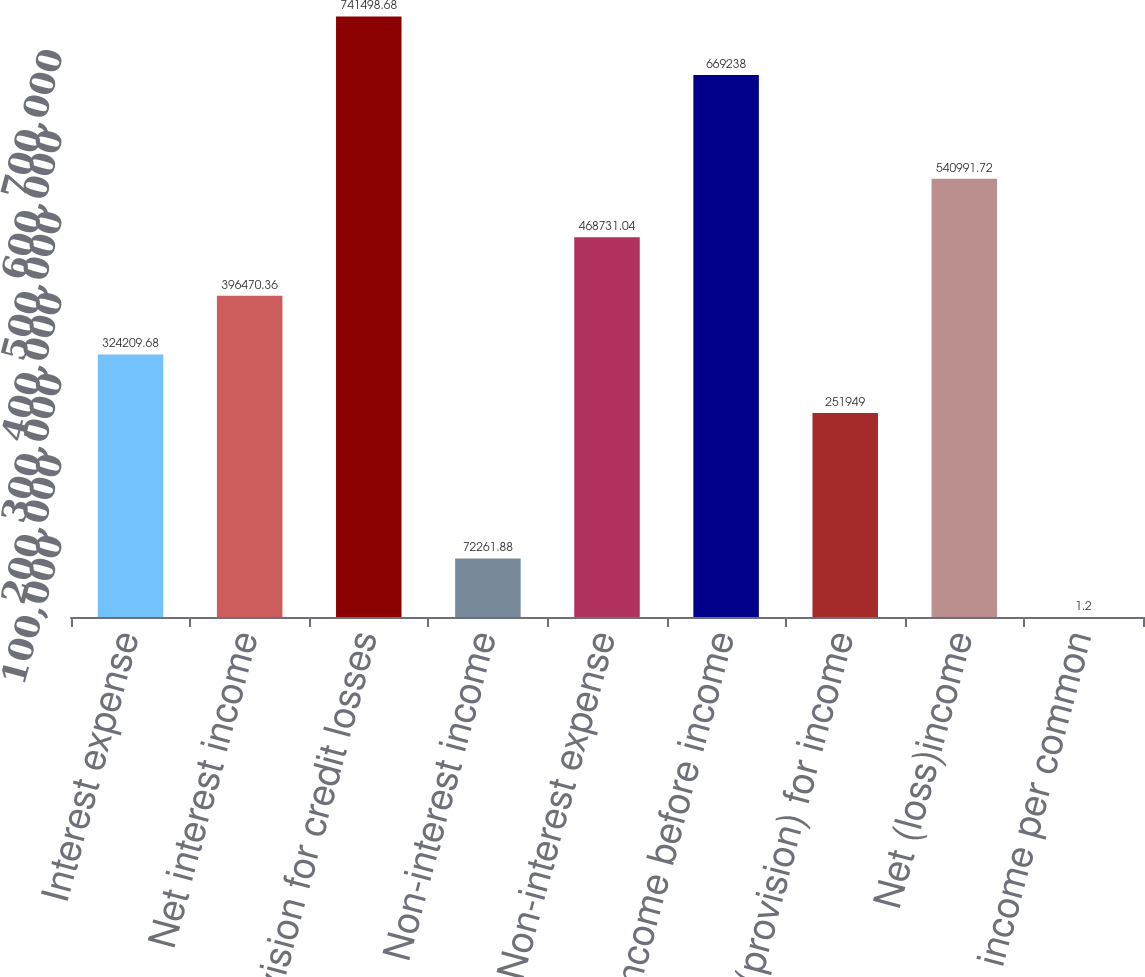<chart> <loc_0><loc_0><loc_500><loc_500><bar_chart><fcel>Interest expense<fcel>Net interest income<fcel>Provision for credit losses<fcel>Non-interest income<fcel>Non-interest expense<fcel>(Loss) income before income<fcel>Benefit(provision) for income<fcel>Net (loss)income<fcel>Net (loss) income per common<nl><fcel>324210<fcel>396470<fcel>741499<fcel>72261.9<fcel>468731<fcel>669238<fcel>251949<fcel>540992<fcel>1.2<nl></chart> 